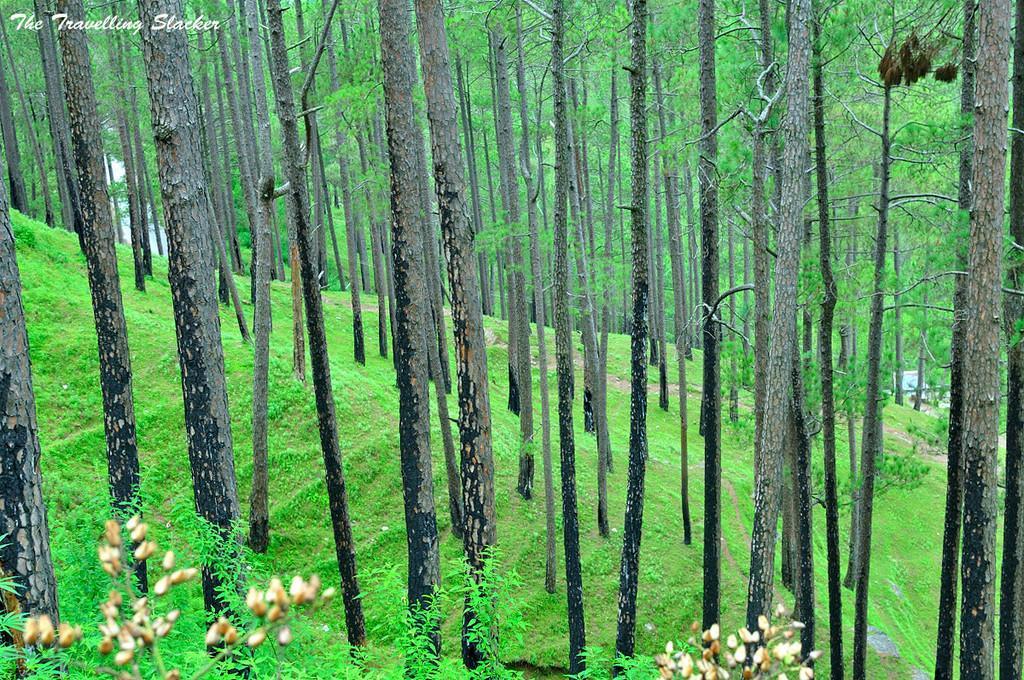Please provide a concise description of this image. In this image I can see the cream color flowers to the plants. In the background I can see the grass and many trees. 